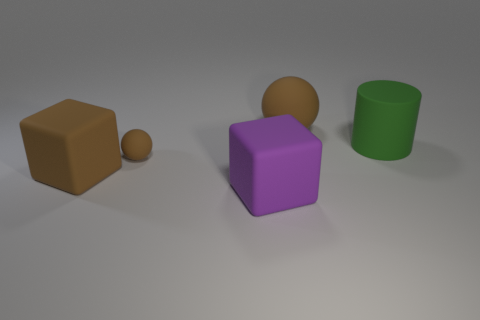How many brown balls must be subtracted to get 1 brown balls? 1 Subtract all balls. How many objects are left? 3 Subtract 1 spheres. How many spheres are left? 1 Subtract all cyan cylinders. Subtract all gray blocks. How many cylinders are left? 1 Subtract all cyan cylinders. How many purple cubes are left? 1 Subtract all large rubber cylinders. Subtract all purple matte cylinders. How many objects are left? 4 Add 5 matte blocks. How many matte blocks are left? 7 Add 2 rubber things. How many rubber things exist? 7 Add 1 yellow rubber blocks. How many objects exist? 6 Subtract all purple blocks. How many blocks are left? 1 